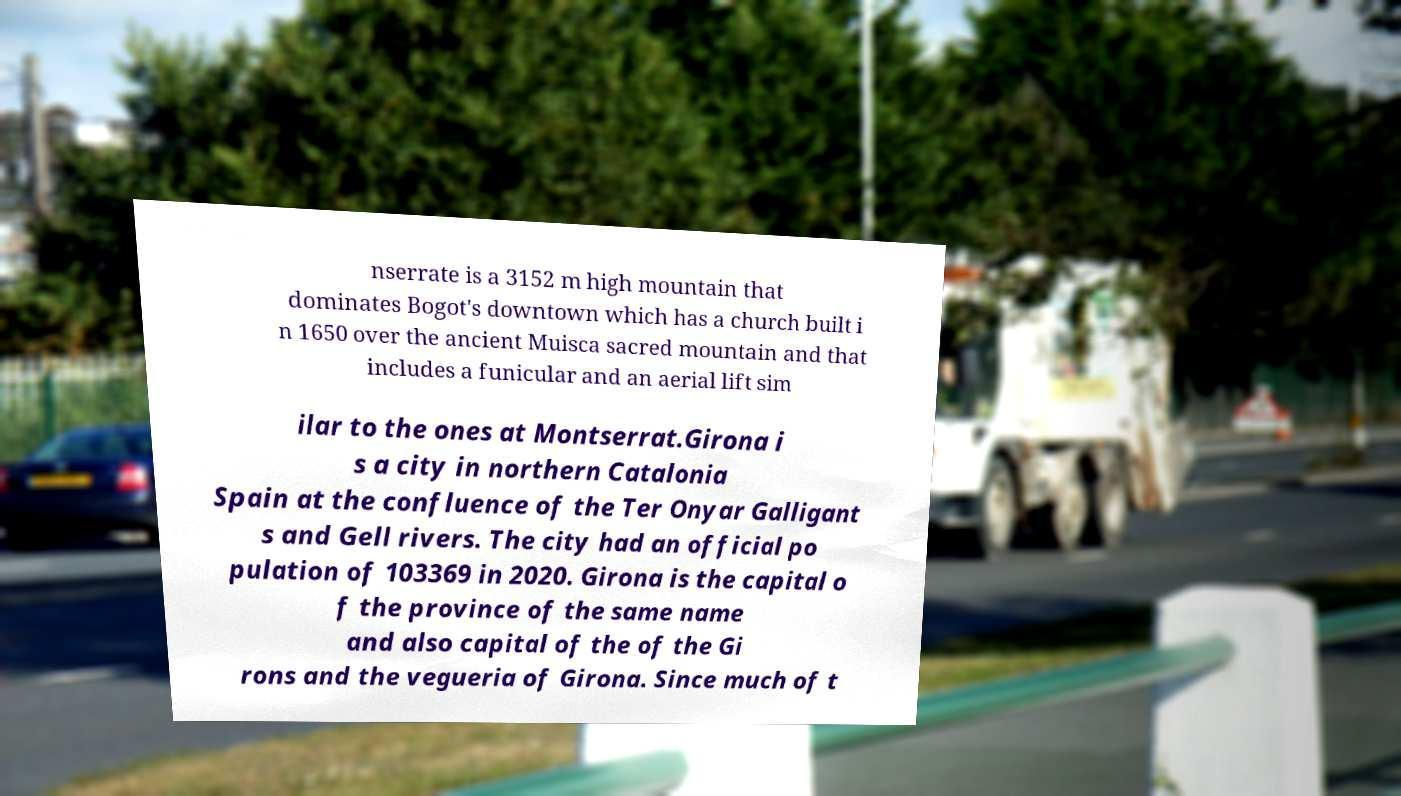There's text embedded in this image that I need extracted. Can you transcribe it verbatim? nserrate is a 3152 m high mountain that dominates Bogot's downtown which has a church built i n 1650 over the ancient Muisca sacred mountain and that includes a funicular and an aerial lift sim ilar to the ones at Montserrat.Girona i s a city in northern Catalonia Spain at the confluence of the Ter Onyar Galligant s and Gell rivers. The city had an official po pulation of 103369 in 2020. Girona is the capital o f the province of the same name and also capital of the of the Gi rons and the vegueria of Girona. Since much of t 